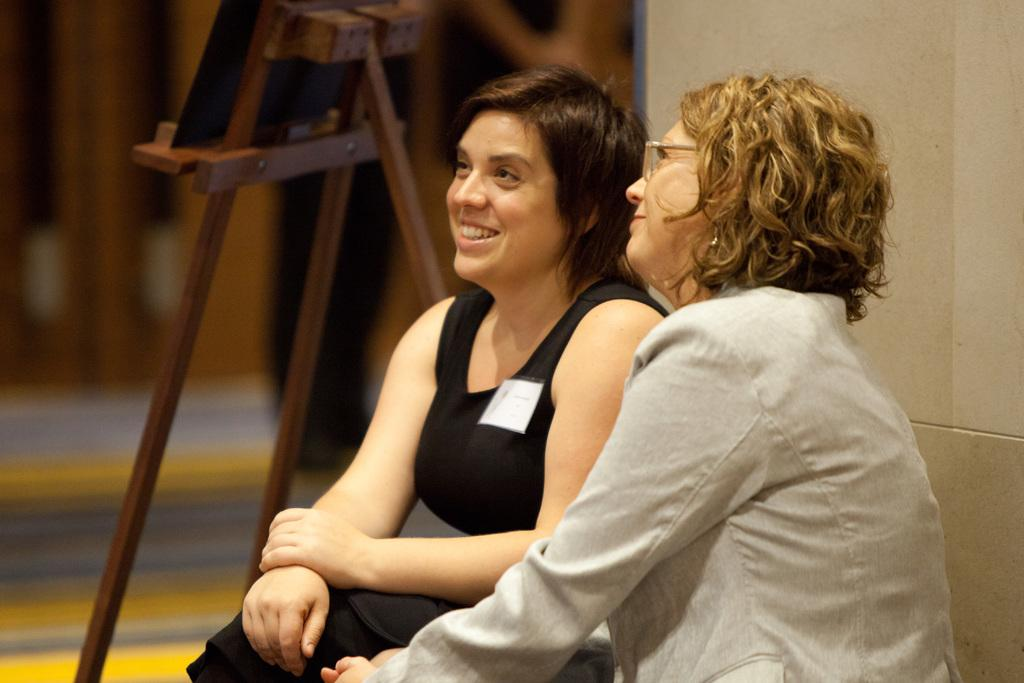How many people are in the image? There are two women in the image. What are the women doing in the image? The women are sitting on the floor. What can be seen in the background of the image? There is a painting board in the background of the image. How many oranges are on the top of the record in the image? There are no oranges or records present in the image. 